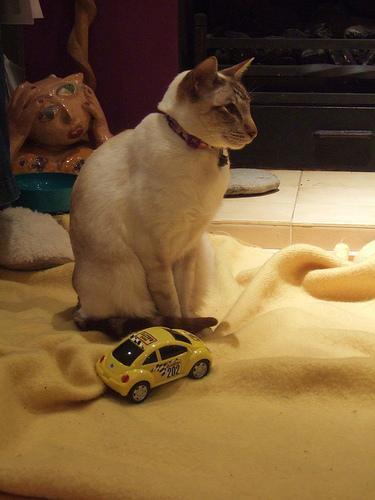How many cats are in the picture?
Give a very brief answer. 1. How many toys are on the floor?
Give a very brief answer. 1. 